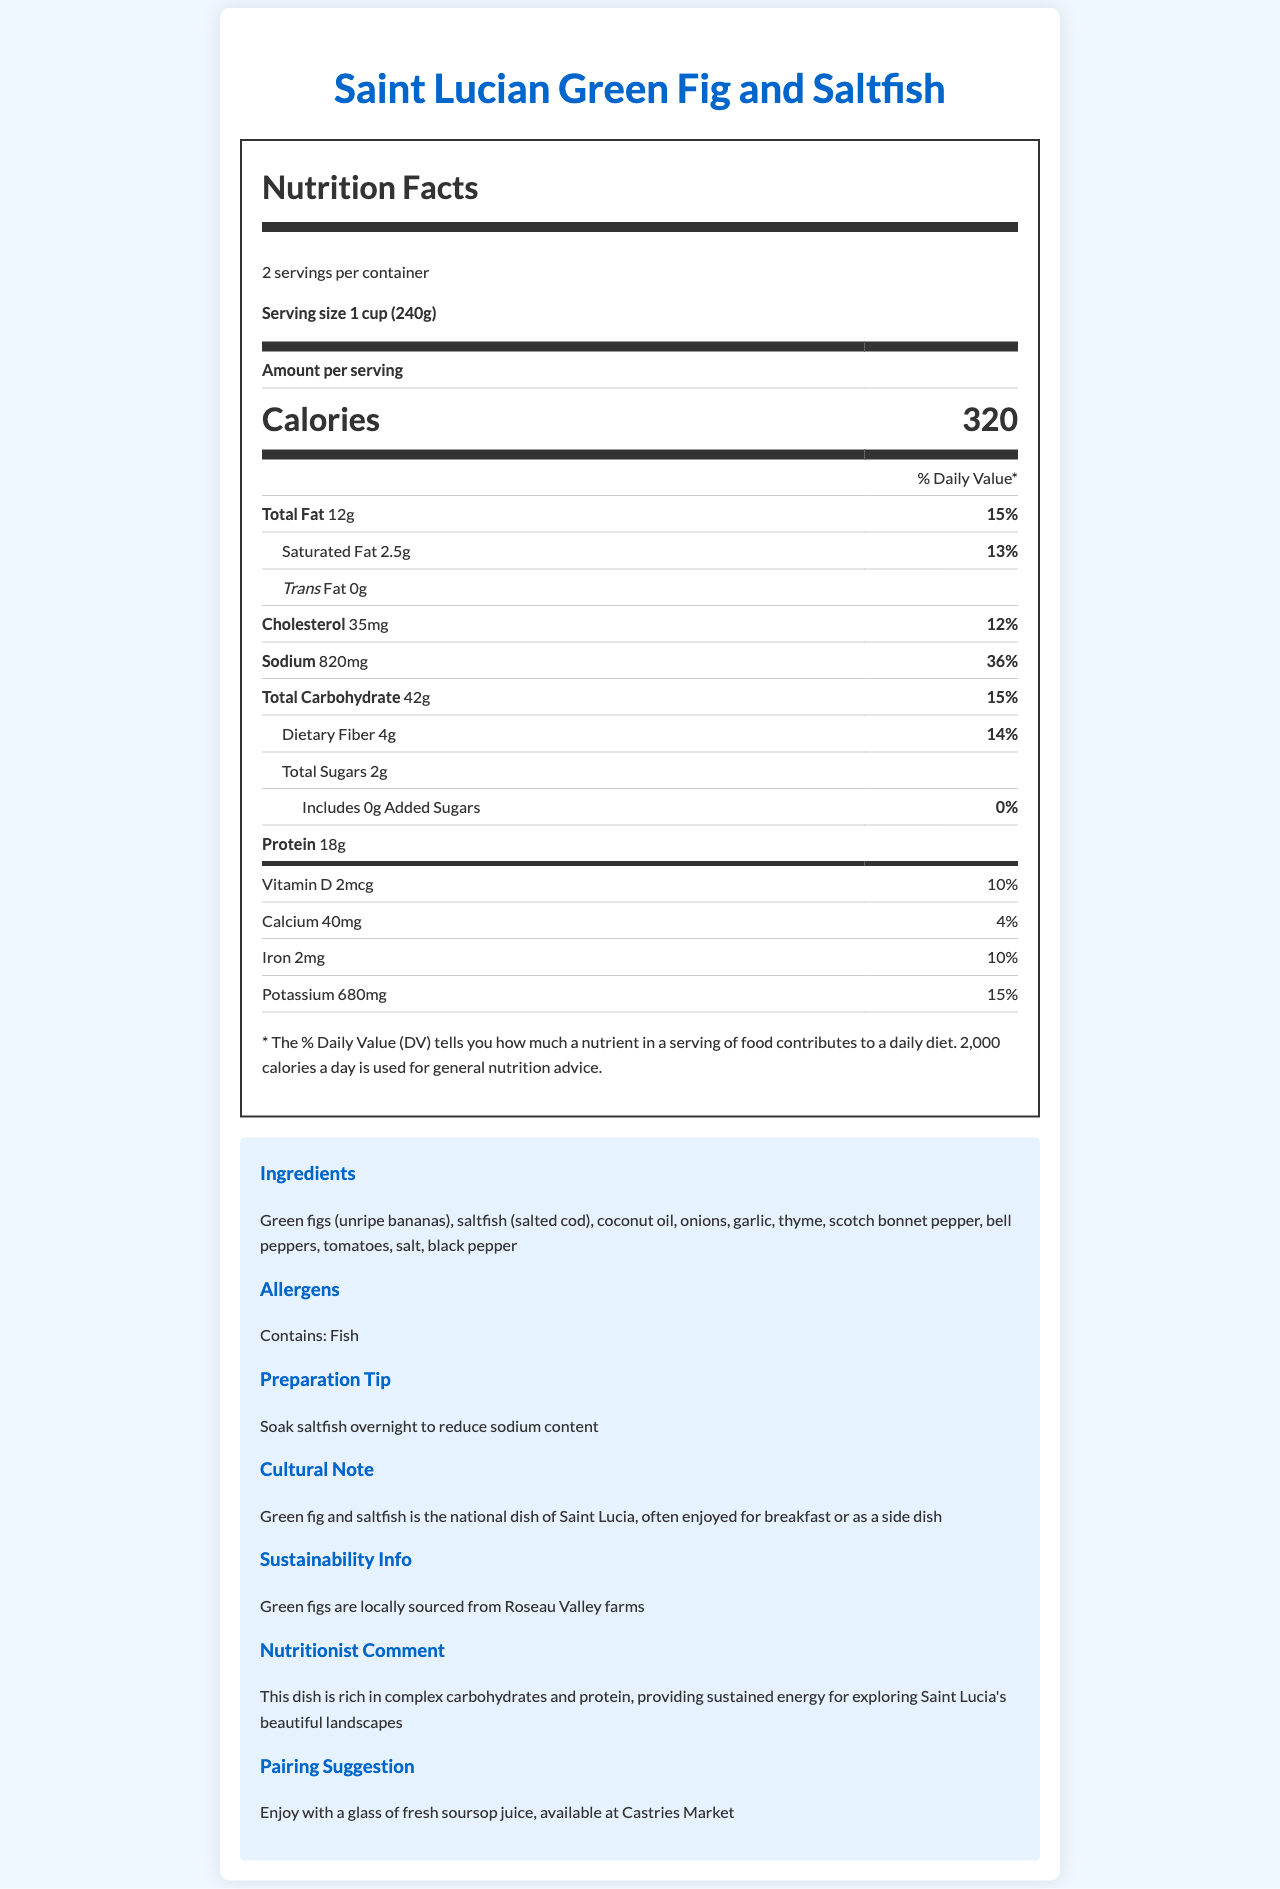what is the serving size for the Saint Lucian green fig and saltfish dish? The document states that the serving size is explicitly mentioned as "1 cup (240g)" in the Nutrition Facts section.
Answer: 1 cup (240g) How many calories are there per serving? The document clearly lists "Calories" as 320 per serving in the nutrition facts.
Answer: 320 calories What is the total fat content per serving? The document states the total fat content as "12g" in the nutrition facts table.
Answer: 12g How much dietary fiber is in one serving? The information on dietary fiber per serving is given as "4g" in the document.
Answer: 4g What percent daily value of sodium does one serving contain? The document mentions that the sodium content per serving accounts for 36% of the daily value.
Answer: 36% How much Vitamin D is in one serving? The document specifies that each serving contains "2mcg" of Vitamin D.
Answer: 2mcg Which of the following ingredients is not listed in the document? A. Green figs B. Chicken C. Thyme D. Coconut oil The ingredients listed are: Green figs, saltfish, coconut oil, onions, garlic, thyme, scotch bonnet pepper, bell peppers, tomatoes, salt, and black pepper. Chicken is not listed.
Answer: B. Chicken What is the national dish of Saint Lucia? A. Aloo Pie B. Jerk Chicken C. Green fig and saltfish D. Callaloo Soup The document clearly mentions that "Green fig and saltfish is the national dish of Saint Lucia".
Answer: C. Green fig and saltfish Is the preparation tip to soak the saltfish to reduce sodium content? The preparation tip in the document specifically advises "Soak saltfish overnight to reduce sodium content".
Answer: Yes What is the total amount of protein provided in one serving? The document indicates that each serving contains 18g of protein.
Answer: 18g How many servings are there in the container? The document states that there are "2 servings per container".
Answer: 2 Explain what the nutritionist says about this dish? The nutritionist's comment in the document highlights the nutritional benefits, emphasizing complex carbohydrates and protein that offer sustained energy.
Answer: The dish is rich in complex carbohydrates and protein, providing sustained energy for exploring Saint Lucia's beautiful landscapes Can you confirm if this dish contains eggs? The document does not provide any information about the presence of eggs in the ingredients or allergens section.
Answer: Cannot be determined Give an overall summary of the Saint Lucian green fig and saltfish dish based on the document. This summary consolidates all provided information to give a comprehensive view of the document's content.
Answer: The document provides detailed nutrition facts for the Saint Lucian green fig and saltfish dish, which is considered the national dish of Saint Lucia. With a serving size of 1 cup (240g) and 2 servings per container, each serving contains 320 calories, 12g total fat, 2.5g saturated fat, 820mg sodium, 42g total carbohydrate, 4g dietary fiber, 2g total sugars, and 18g protein. The dish ingredients include green figs, saltfish, coconut oil, various vegetables, and spices. It contains fish allergens. A nutritionist notes that the dish is rich in complex carbohydrates and protein, providing energy. The document also mentions that green figs are locally sourced, and suggests pairing the dish with fresh soursop juice. 